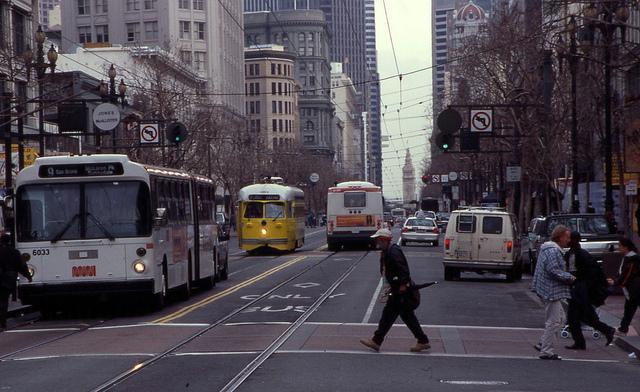How many buses are on the street?
Give a very brief answer. 3. How many cyclist are present?
Give a very brief answer. 0. How many cars can you see?
Give a very brief answer. 2. How many people are there?
Give a very brief answer. 3. How many buses are there?
Give a very brief answer. 2. 